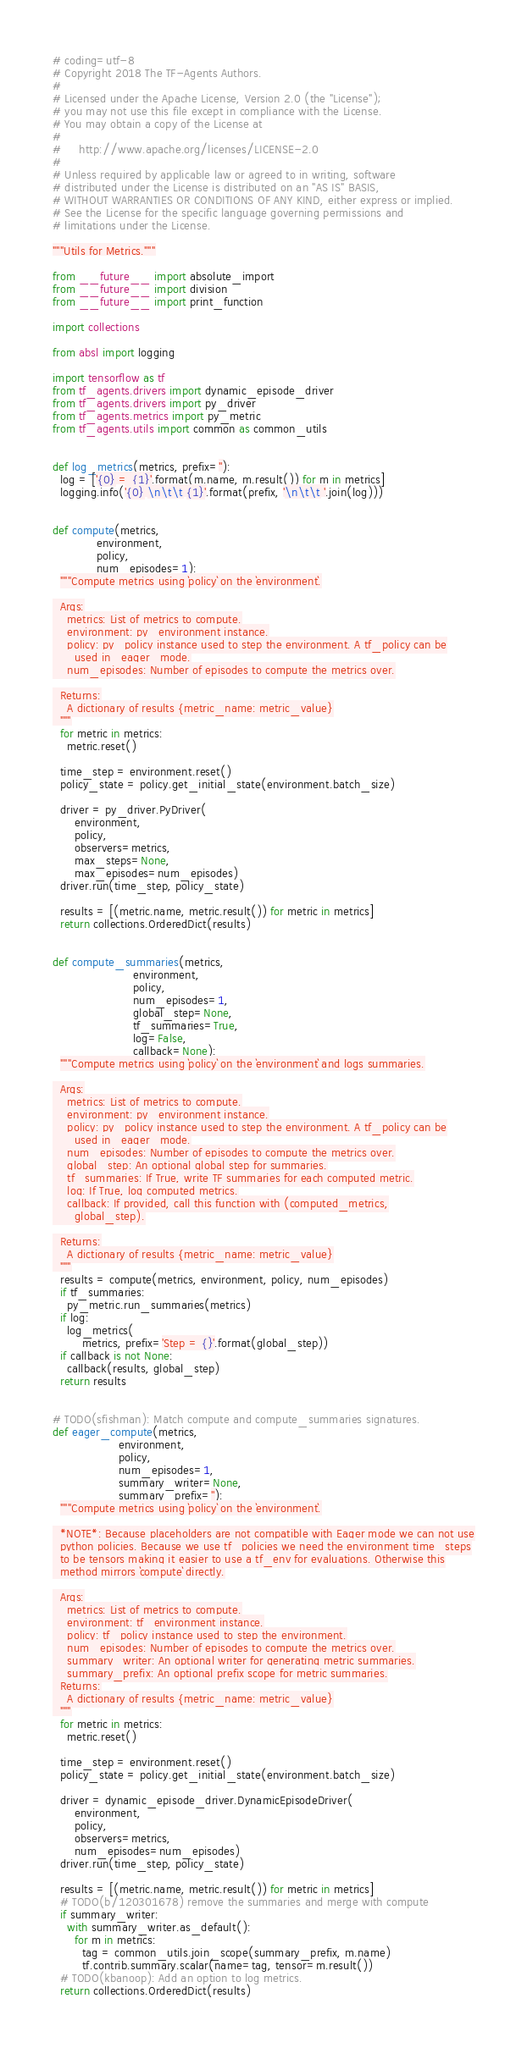<code> <loc_0><loc_0><loc_500><loc_500><_Python_># coding=utf-8
# Copyright 2018 The TF-Agents Authors.
#
# Licensed under the Apache License, Version 2.0 (the "License");
# you may not use this file except in compliance with the License.
# You may obtain a copy of the License at
#
#     http://www.apache.org/licenses/LICENSE-2.0
#
# Unless required by applicable law or agreed to in writing, software
# distributed under the License is distributed on an "AS IS" BASIS,
# WITHOUT WARRANTIES OR CONDITIONS OF ANY KIND, either express or implied.
# See the License for the specific language governing permissions and
# limitations under the License.

"""Utils for Metrics."""

from __future__ import absolute_import
from __future__ import division
from __future__ import print_function

import collections

from absl import logging

import tensorflow as tf
from tf_agents.drivers import dynamic_episode_driver
from tf_agents.drivers import py_driver
from tf_agents.metrics import py_metric
from tf_agents.utils import common as common_utils


def log_metrics(metrics, prefix=''):
  log = ['{0} = {1}'.format(m.name, m.result()) for m in metrics]
  logging.info('{0} \n\t\t {1}'.format(prefix, '\n\t\t '.join(log)))


def compute(metrics,
            environment,
            policy,
            num_episodes=1):
  """Compute metrics using `policy` on the `environment`.

  Args:
    metrics: List of metrics to compute.
    environment: py_environment instance.
    policy: py_policy instance used to step the environment. A tf_policy can be
      used in_eager_mode.
    num_episodes: Number of episodes to compute the metrics over.

  Returns:
    A dictionary of results {metric_name: metric_value}
  """
  for metric in metrics:
    metric.reset()

  time_step = environment.reset()
  policy_state = policy.get_initial_state(environment.batch_size)

  driver = py_driver.PyDriver(
      environment,
      policy,
      observers=metrics,
      max_steps=None,
      max_episodes=num_episodes)
  driver.run(time_step, policy_state)

  results = [(metric.name, metric.result()) for metric in metrics]
  return collections.OrderedDict(results)


def compute_summaries(metrics,
                      environment,
                      policy,
                      num_episodes=1,
                      global_step=None,
                      tf_summaries=True,
                      log=False,
                      callback=None):
  """Compute metrics using `policy` on the `environment` and logs summaries.

  Args:
    metrics: List of metrics to compute.
    environment: py_environment instance.
    policy: py_policy instance used to step the environment. A tf_policy can be
      used in_eager_mode.
    num_episodes: Number of episodes to compute the metrics over.
    global_step: An optional global step for summaries.
    tf_summaries: If True, write TF summaries for each computed metric.
    log: If True, log computed metrics.
    callback: If provided, call this function with (computed_metrics,
      global_step).

  Returns:
    A dictionary of results {metric_name: metric_value}
  """
  results = compute(metrics, environment, policy, num_episodes)
  if tf_summaries:
    py_metric.run_summaries(metrics)
  if log:
    log_metrics(
        metrics, prefix='Step = {}'.format(global_step))
  if callback is not None:
    callback(results, global_step)
  return results


# TODO(sfishman): Match compute and compute_summaries signatures.
def eager_compute(metrics,
                  environment,
                  policy,
                  num_episodes=1,
                  summary_writer=None,
                  summary_prefix=''):
  """Compute metrics using `policy` on the `environment`.

  *NOTE*: Because placeholders are not compatible with Eager mode we can not use
  python policies. Because we use tf_policies we need the environment time_steps
  to be tensors making it easier to use a tf_env for evaluations. Otherwise this
  method mirrors `compute` directly.

  Args:
    metrics: List of metrics to compute.
    environment: tf_environment instance.
    policy: tf_policy instance used to step the environment.
    num_episodes: Number of episodes to compute the metrics over.
    summary_writer: An optional writer for generating metric summaries.
    summary_prefix: An optional prefix scope for metric summaries.
  Returns:
    A dictionary of results {metric_name: metric_value}
  """
  for metric in metrics:
    metric.reset()

  time_step = environment.reset()
  policy_state = policy.get_initial_state(environment.batch_size)

  driver = dynamic_episode_driver.DynamicEpisodeDriver(
      environment,
      policy,
      observers=metrics,
      num_episodes=num_episodes)
  driver.run(time_step, policy_state)

  results = [(metric.name, metric.result()) for metric in metrics]
  # TODO(b/120301678) remove the summaries and merge with compute
  if summary_writer:
    with summary_writer.as_default():
      for m in metrics:
        tag = common_utils.join_scope(summary_prefix, m.name)
        tf.contrib.summary.scalar(name=tag, tensor=m.result())
  # TODO(kbanoop): Add an option to log metrics.
  return collections.OrderedDict(results)
</code> 